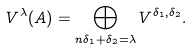<formula> <loc_0><loc_0><loc_500><loc_500>V ^ { \lambda } ( A ) = \bigoplus _ { n \delta _ { 1 } + \delta _ { 2 } = \lambda } V ^ { \delta _ { 1 } , \delta _ { 2 } } .</formula> 